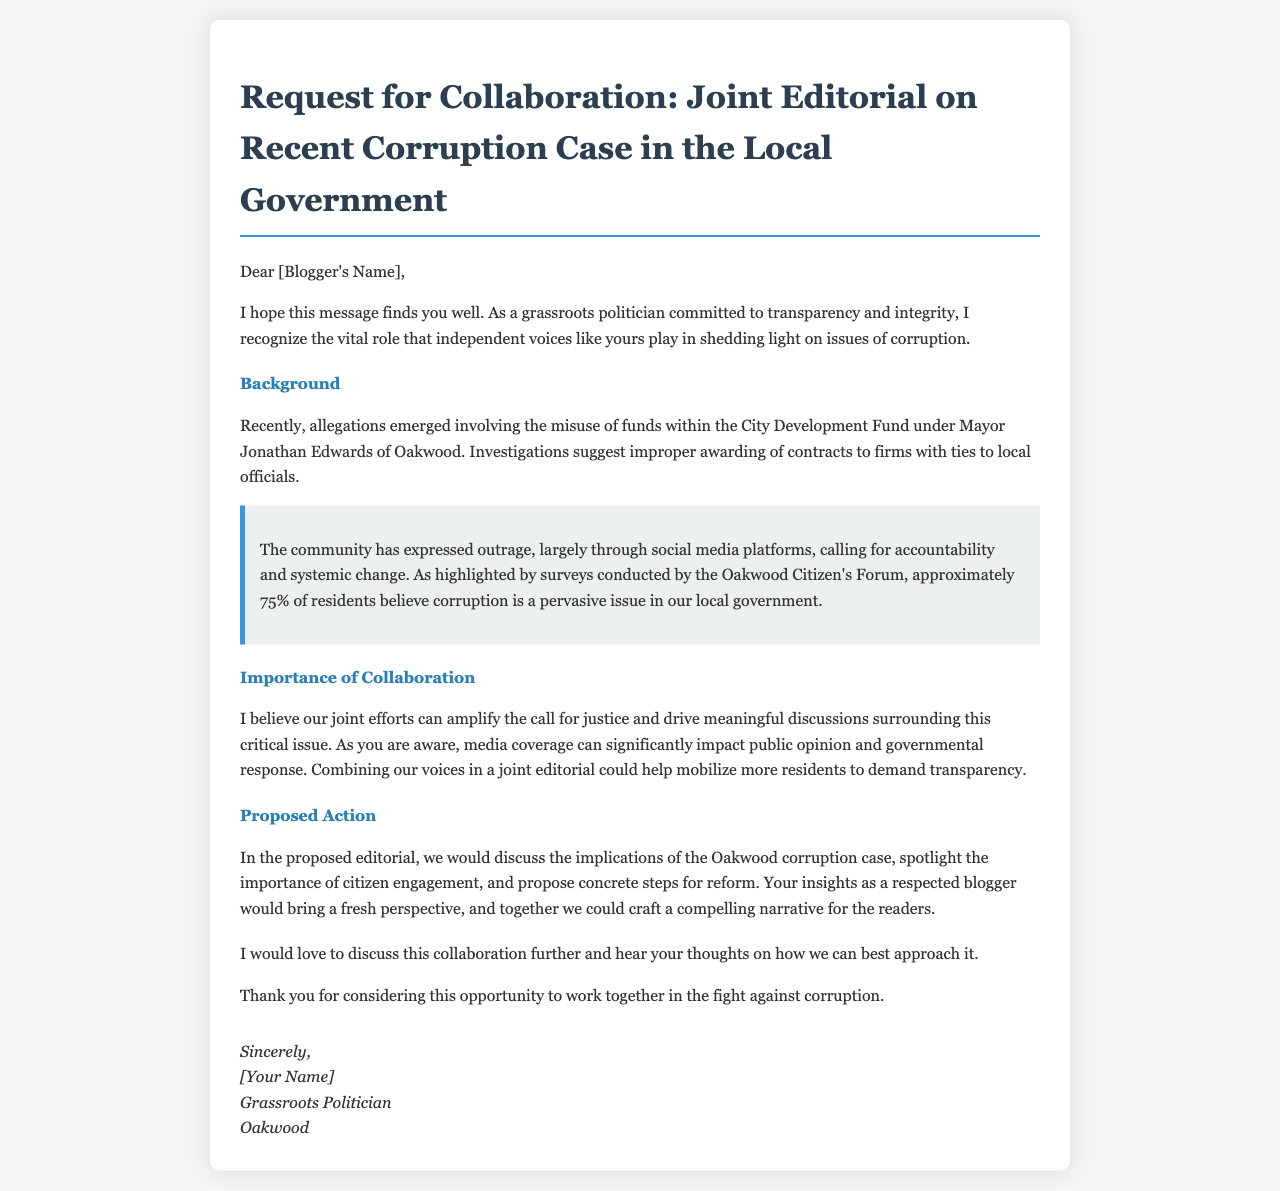What is the name of the Mayor involved in the allegations? The name of the Mayor mentioned in the document is Jonathan Edwards.
Answer: Jonathan Edwards What percentage of residents believe corruption is a pervasive issue? The document states that approximately 75% of residents believe corruption is a pervasive issue.
Answer: 75% What is the focus of the proposed joint editorial? The proposed joint editorial would discuss the implications of the Oakwood corruption case and propose concrete steps for reform.
Answer: Implications of the Oakwood corruption case What role does the blogger play according to the letter? The letter indicates that the blogger plays a vital role in shedding light on issues of corruption.
Answer: Vital role What community response is highlighted in the document? The community has expressed outrage largely through social media platforms.
Answer: Social media platforms What is the aim of the proposed collaboration? The aim is to amplify the call for justice and drive discussions surrounding the corruption issue.
Answer: Amplify the call for justice What does the Grassroots Politician request from the blogger? The Grassroots Politician requests to discuss the collaboration further and hear the blogger's thoughts.
Answer: Discuss the collaboration What is the tone of the letter? The letter conveys a tone of urgency and collaboration in addressing corruption.
Answer: Urgency and collaboration 